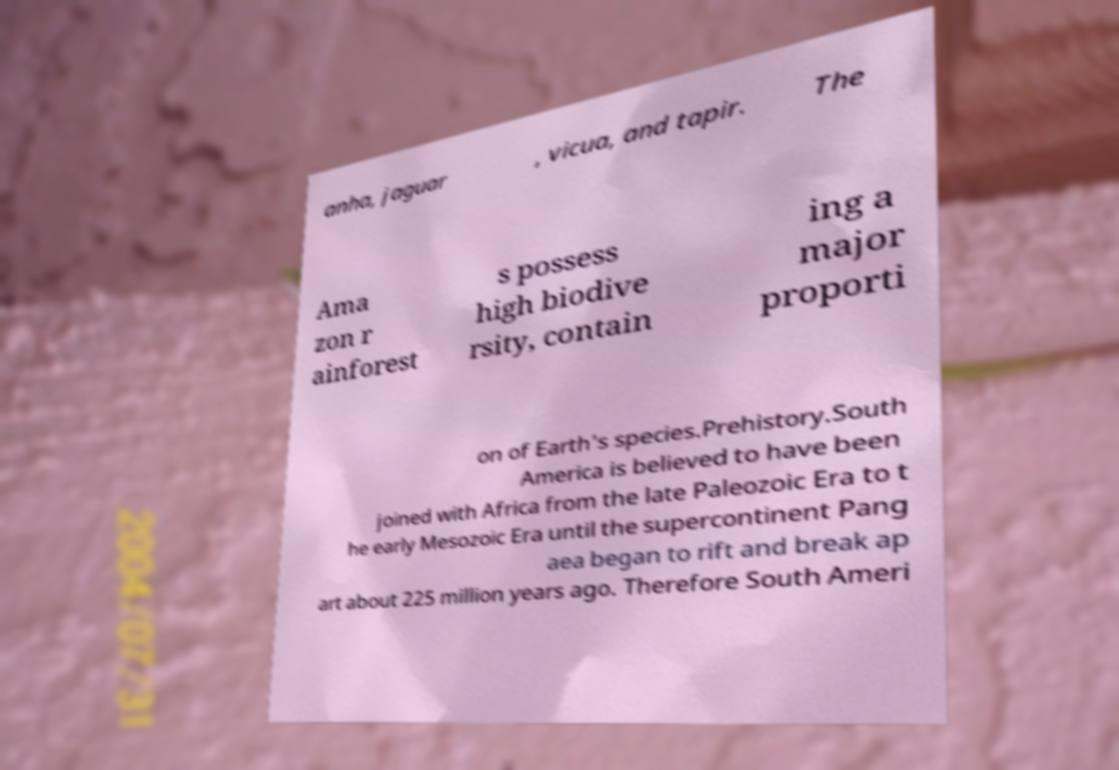For documentation purposes, I need the text within this image transcribed. Could you provide that? anha, jaguar , vicua, and tapir. The Ama zon r ainforest s possess high biodive rsity, contain ing a major proporti on of Earth's species.Prehistory.South America is believed to have been joined with Africa from the late Paleozoic Era to t he early Mesozoic Era until the supercontinent Pang aea began to rift and break ap art about 225 million years ago. Therefore South Ameri 